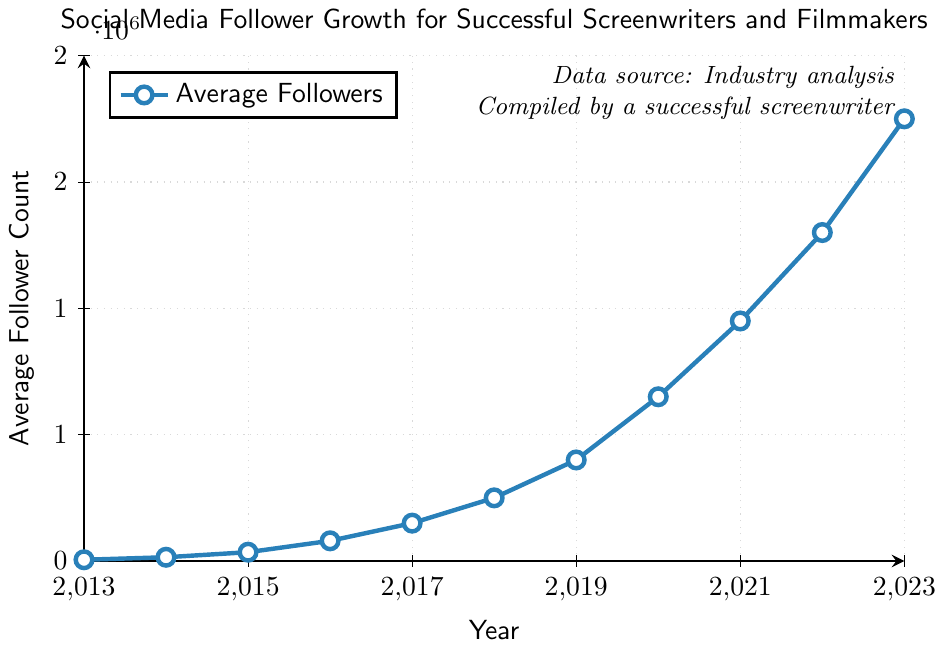How many more followers did screenwriters and filmmakers gain on average between 2014 and 2016? To find the number of followers gained, subtract the follower count in 2014 from the count in 2016: 80000 - 15000 = 65000
Answer: 65000 In which year did the follower count first exceed 500,000? The chart shows the follower count first exceeded 500,000 in 2019 when it reached 400,000 the year before and 650,000 in 2019
Answer: 2019 What is the increase in average followers between 2019 and 2023? To find the increase, subtract the follower count in 2019 from the 2023 count: 1750000 - 400000 = 1350000
Answer: 1350000 Compare the follower growth rate between 2016-2017 and 2021-2022. Which period had a higher growth rate? For 2016-2017: (150000 - 80000) / 80000 = 0.875. For 2021-2022: (1300000 - 950000) / 950000 = 0.368. The growth rate is higher for 2016-2017
Answer: 2016-2017 What was the average annual increase in followers between 2013 and 2023? The total increase over the decade is 1750000 - 5000 = 1745000. There are 10 years between 2013 and 2023. So, the average annual increase is 1745000 / 10 = 174500
Answer: 174500 In which years did the follower count increase by exactly 200,000 or more compared to the previous year? The follower counts increased by 200,000 or more between 2019 and 2020 (250000), 2020 and 2021 (300000), 2021 and 2022 (350000), and 2022 and 2023 (450000)
Answer: 2019-2020, 2020-2021, 2021-2022, 2022-2023 What was the number of followers in 2018 compared to 2016? Referring to the chart, in 2018, the count was 250000, and in 2016, it was 80000. 250000 is greater than 80000
Answer: Greater in 2018 Does the line representing the follower count ever decline? Visually inspect the line on the chart and observe that it only rises, indicating no decline in followers
Answer: No 